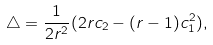Convert formula to latex. <formula><loc_0><loc_0><loc_500><loc_500>\triangle = \frac { 1 } { 2 r ^ { 2 } } ( 2 r c _ { 2 } - ( r - 1 ) c _ { 1 } ^ { 2 } ) ,</formula> 